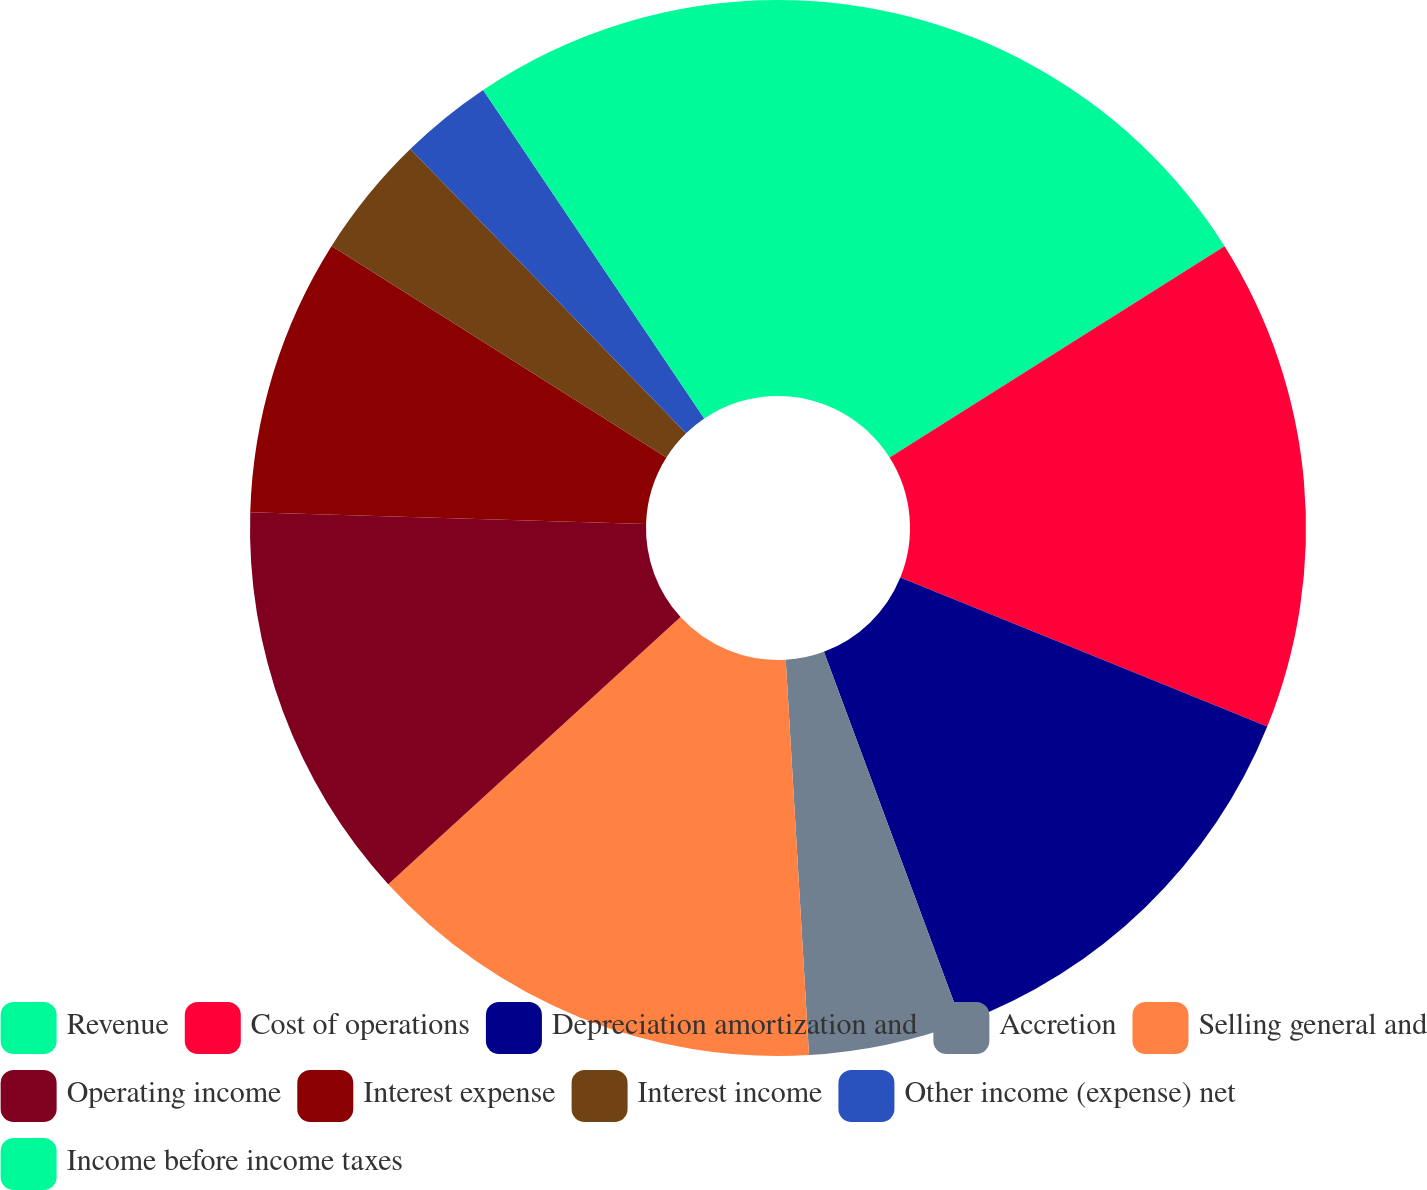Convert chart to OTSL. <chart><loc_0><loc_0><loc_500><loc_500><pie_chart><fcel>Revenue<fcel>Cost of operations<fcel>Depreciation amortization and<fcel>Accretion<fcel>Selling general and<fcel>Operating income<fcel>Interest expense<fcel>Interest income<fcel>Other income (expense) net<fcel>Income before income taxes<nl><fcel>16.04%<fcel>15.09%<fcel>13.21%<fcel>4.72%<fcel>14.15%<fcel>12.26%<fcel>8.49%<fcel>3.77%<fcel>2.83%<fcel>9.43%<nl></chart> 